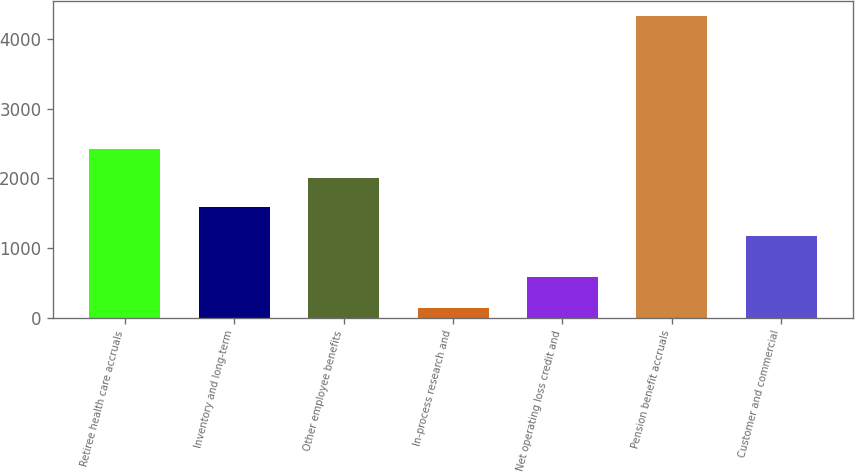<chart> <loc_0><loc_0><loc_500><loc_500><bar_chart><fcel>Retiree health care accruals<fcel>Inventory and long-term<fcel>Other employee benefits<fcel>In-process research and<fcel>Net operating loss credit and<fcel>Pension benefit accruals<fcel>Customer and commercial<nl><fcel>2425<fcel>1587<fcel>2006<fcel>142<fcel>587<fcel>4332<fcel>1168<nl></chart> 